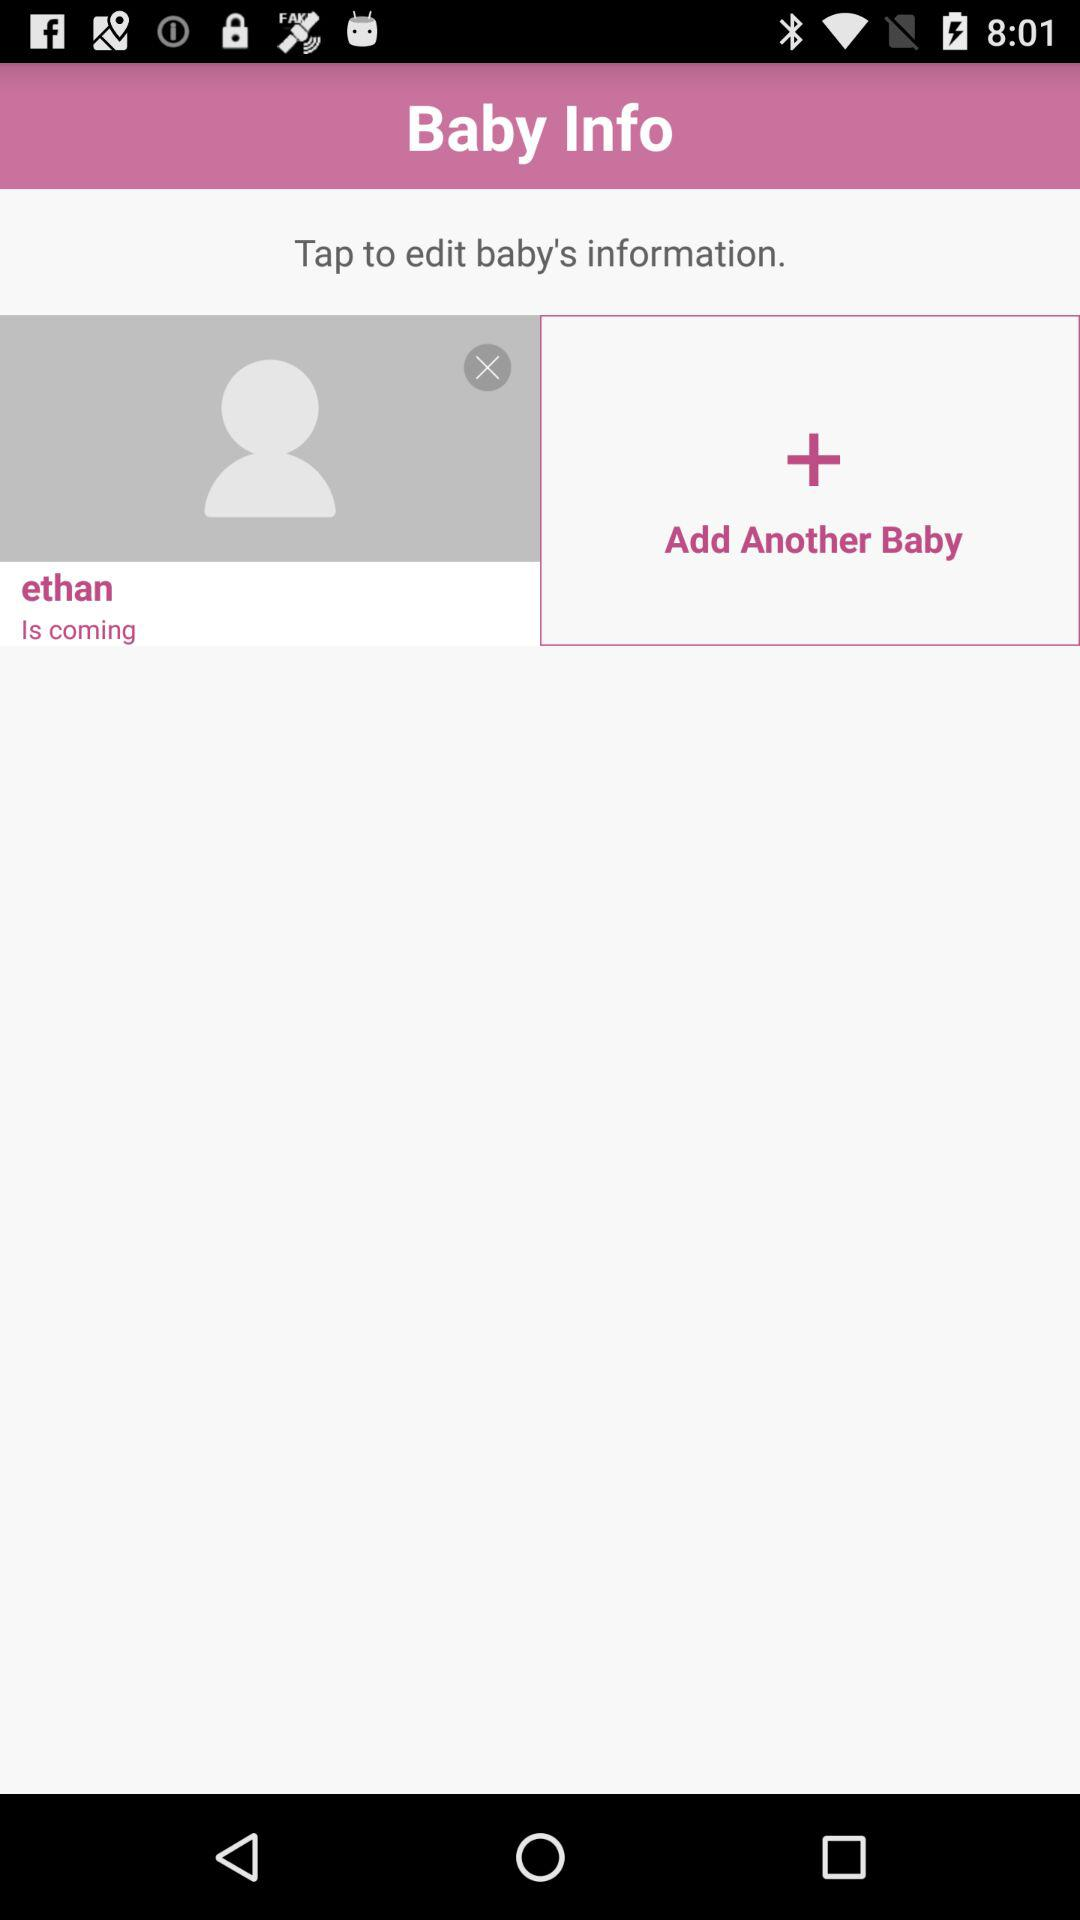How many babies can be added in total?
When the provided information is insufficient, respond with <no answer>. <no answer> 